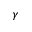<formula> <loc_0><loc_0><loc_500><loc_500>\gamma</formula> 